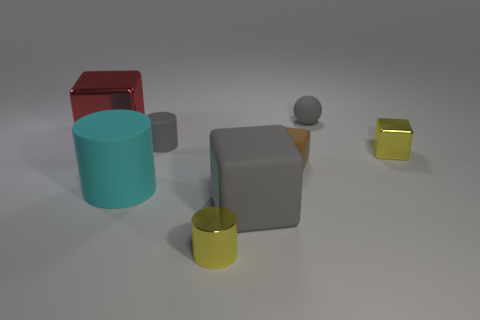How many yellow things are tiny rubber balls or big blocks?
Your answer should be very brief. 0. There is a thing that is both behind the small rubber cylinder and to the right of the yellow metallic cylinder; what size is it?
Give a very brief answer. Small. Is the number of big gray matte objects that are to the left of the gray ball greater than the number of small red metal spheres?
Keep it short and to the point. Yes. What number of balls are either brown matte things or cyan objects?
Your answer should be very brief. 0. What shape is the matte object that is left of the yellow metal cylinder and behind the cyan thing?
Make the answer very short. Cylinder. Are there an equal number of small brown objects that are left of the shiny cylinder and big things that are on the right side of the big rubber cylinder?
Your response must be concise. No. How many things are big blue matte cubes or yellow objects?
Ensure brevity in your answer.  2. There is a matte cylinder that is the same size as the red shiny thing; what is its color?
Offer a very short reply. Cyan. How many objects are large blocks that are left of the tiny shiny cylinder or small objects to the right of the big cylinder?
Your response must be concise. 6. Is the number of gray spheres that are left of the gray rubber cube the same as the number of tiny cyan matte cylinders?
Give a very brief answer. Yes. 